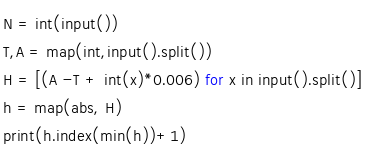Convert code to text. <code><loc_0><loc_0><loc_500><loc_500><_Python_>N = int(input())
T,A = map(int,input().split())
H = [(A -T + int(x)*0.006) for x in input().split()]
h = map(abs, H)
print(h.index(min(h))+1)</code> 